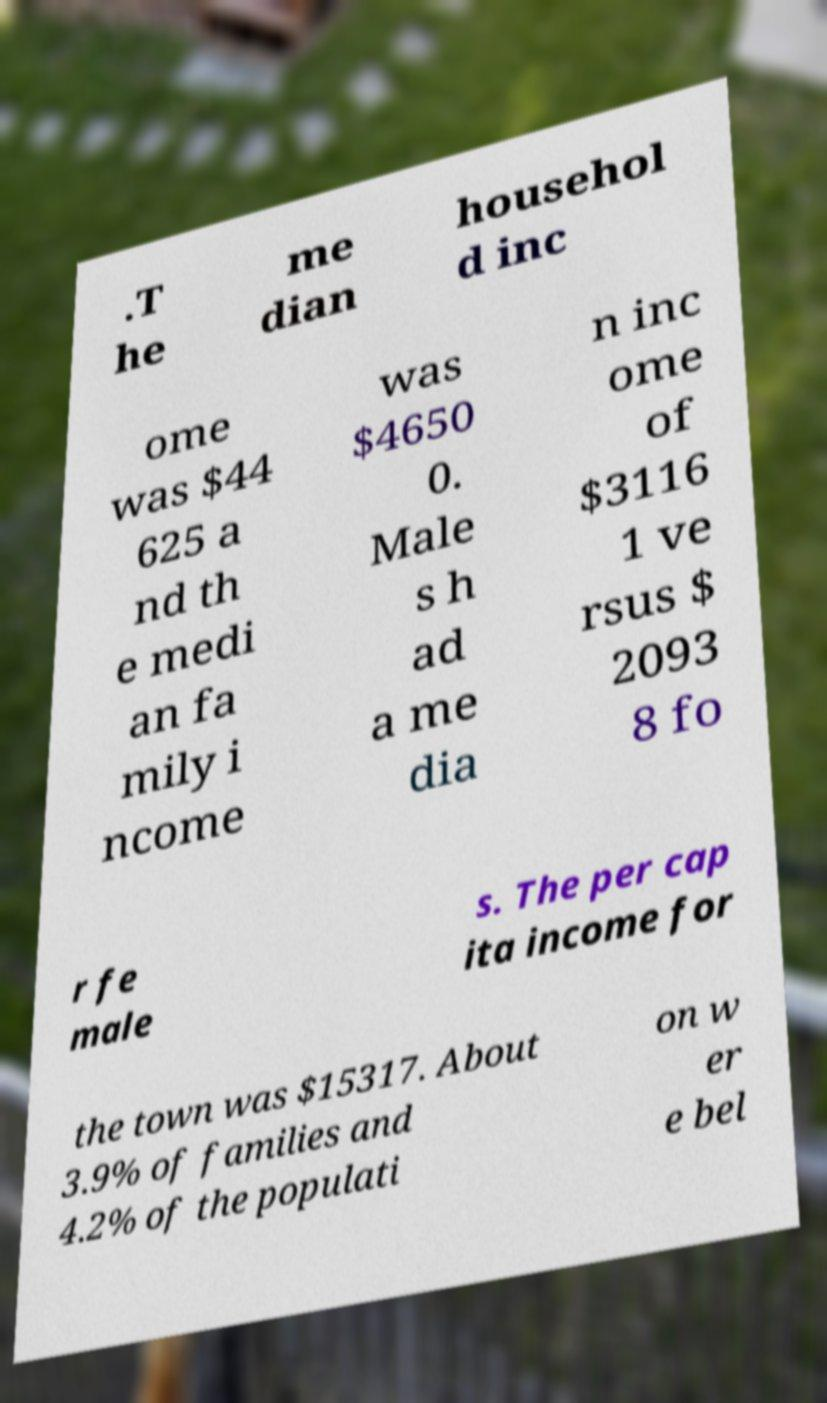I need the written content from this picture converted into text. Can you do that? .T he me dian househol d inc ome was $44 625 a nd th e medi an fa mily i ncome was $4650 0. Male s h ad a me dia n inc ome of $3116 1 ve rsus $ 2093 8 fo r fe male s. The per cap ita income for the town was $15317. About 3.9% of families and 4.2% of the populati on w er e bel 